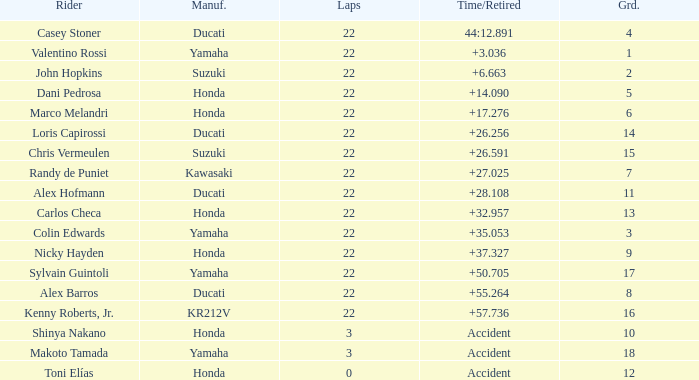What was the average amount of laps for competitors with a grid that was more than 11 and a Time/Retired of +28.108? None. 